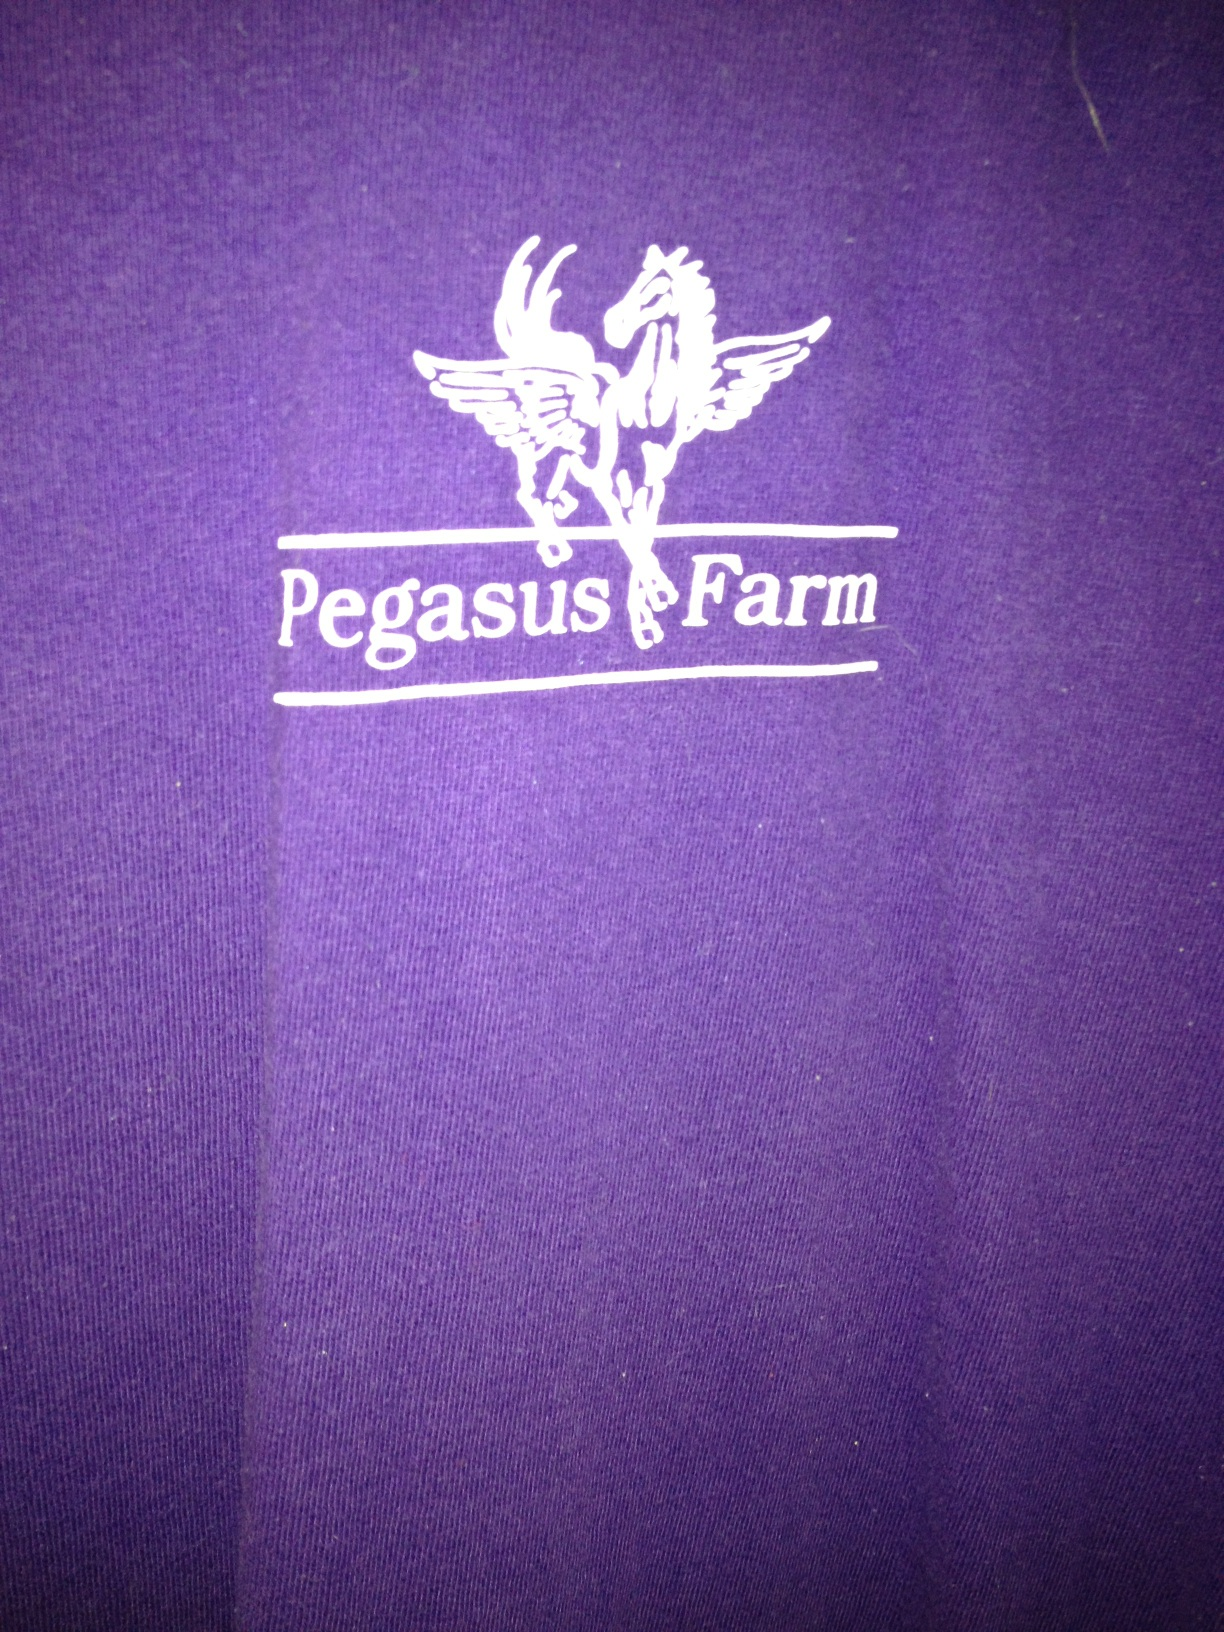Can you please tell me what color my shirt is? Thank you. Certainly! The shirt in the image is a rich shade of purple, and it also features an interesting graphic with the text 'Pegasus Farm' on it. 